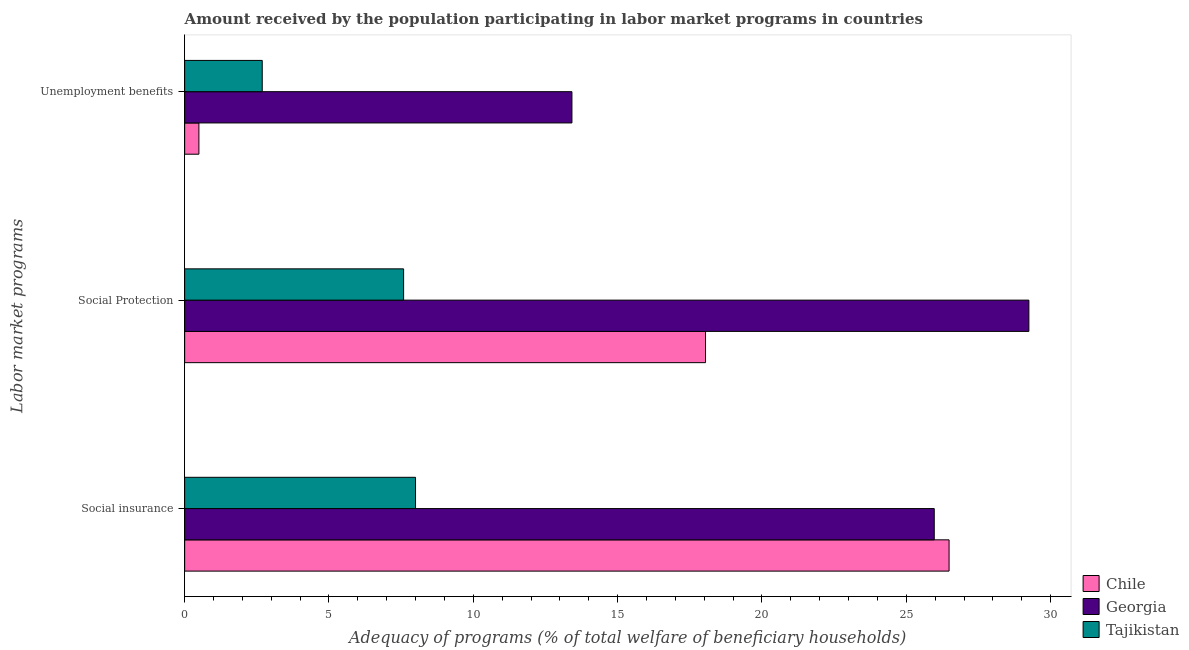How many groups of bars are there?
Offer a very short reply. 3. Are the number of bars per tick equal to the number of legend labels?
Give a very brief answer. Yes. How many bars are there on the 1st tick from the top?
Your answer should be compact. 3. How many bars are there on the 1st tick from the bottom?
Provide a succinct answer. 3. What is the label of the 1st group of bars from the top?
Give a very brief answer. Unemployment benefits. What is the amount received by the population participating in social insurance programs in Georgia?
Your answer should be compact. 25.97. Across all countries, what is the maximum amount received by the population participating in social insurance programs?
Ensure brevity in your answer.  26.48. Across all countries, what is the minimum amount received by the population participating in unemployment benefits programs?
Provide a short and direct response. 0.49. In which country was the amount received by the population participating in social insurance programs maximum?
Give a very brief answer. Chile. In which country was the amount received by the population participating in social protection programs minimum?
Your response must be concise. Tajikistan. What is the total amount received by the population participating in unemployment benefits programs in the graph?
Your answer should be compact. 16.6. What is the difference between the amount received by the population participating in social insurance programs in Georgia and that in Tajikistan?
Ensure brevity in your answer.  17.97. What is the difference between the amount received by the population participating in social protection programs in Chile and the amount received by the population participating in social insurance programs in Georgia?
Keep it short and to the point. -7.92. What is the average amount received by the population participating in social protection programs per country?
Your response must be concise. 18.29. What is the difference between the amount received by the population participating in unemployment benefits programs and amount received by the population participating in social insurance programs in Chile?
Make the answer very short. -25.99. What is the ratio of the amount received by the population participating in unemployment benefits programs in Tajikistan to that in Chile?
Your response must be concise. 5.44. Is the amount received by the population participating in social insurance programs in Tajikistan less than that in Georgia?
Offer a very short reply. Yes. What is the difference between the highest and the second highest amount received by the population participating in social insurance programs?
Ensure brevity in your answer.  0.51. What is the difference between the highest and the lowest amount received by the population participating in unemployment benefits programs?
Ensure brevity in your answer.  12.92. Is the sum of the amount received by the population participating in social protection programs in Chile and Tajikistan greater than the maximum amount received by the population participating in unemployment benefits programs across all countries?
Provide a succinct answer. Yes. What does the 2nd bar from the top in Social Protection represents?
Your answer should be compact. Georgia. What does the 3rd bar from the bottom in Social Protection represents?
Ensure brevity in your answer.  Tajikistan. Are all the bars in the graph horizontal?
Ensure brevity in your answer.  Yes. How many countries are there in the graph?
Your response must be concise. 3. Are the values on the major ticks of X-axis written in scientific E-notation?
Offer a very short reply. No. Does the graph contain grids?
Provide a short and direct response. No. How many legend labels are there?
Offer a terse response. 3. What is the title of the graph?
Make the answer very short. Amount received by the population participating in labor market programs in countries. Does "Arab World" appear as one of the legend labels in the graph?
Make the answer very short. No. What is the label or title of the X-axis?
Give a very brief answer. Adequacy of programs (% of total welfare of beneficiary households). What is the label or title of the Y-axis?
Ensure brevity in your answer.  Labor market programs. What is the Adequacy of programs (% of total welfare of beneficiary households) of Chile in Social insurance?
Your response must be concise. 26.48. What is the Adequacy of programs (% of total welfare of beneficiary households) of Georgia in Social insurance?
Your response must be concise. 25.97. What is the Adequacy of programs (% of total welfare of beneficiary households) of Tajikistan in Social insurance?
Provide a short and direct response. 8. What is the Adequacy of programs (% of total welfare of beneficiary households) in Chile in Social Protection?
Give a very brief answer. 18.05. What is the Adequacy of programs (% of total welfare of beneficiary households) in Georgia in Social Protection?
Your answer should be compact. 29.25. What is the Adequacy of programs (% of total welfare of beneficiary households) in Tajikistan in Social Protection?
Offer a terse response. 7.59. What is the Adequacy of programs (% of total welfare of beneficiary households) of Chile in Unemployment benefits?
Provide a succinct answer. 0.49. What is the Adequacy of programs (% of total welfare of beneficiary households) in Georgia in Unemployment benefits?
Your response must be concise. 13.42. What is the Adequacy of programs (% of total welfare of beneficiary households) of Tajikistan in Unemployment benefits?
Provide a short and direct response. 2.69. Across all Labor market programs, what is the maximum Adequacy of programs (% of total welfare of beneficiary households) of Chile?
Keep it short and to the point. 26.48. Across all Labor market programs, what is the maximum Adequacy of programs (% of total welfare of beneficiary households) in Georgia?
Your answer should be compact. 29.25. Across all Labor market programs, what is the maximum Adequacy of programs (% of total welfare of beneficiary households) of Tajikistan?
Offer a very short reply. 8. Across all Labor market programs, what is the minimum Adequacy of programs (% of total welfare of beneficiary households) in Chile?
Provide a short and direct response. 0.49. Across all Labor market programs, what is the minimum Adequacy of programs (% of total welfare of beneficiary households) of Georgia?
Your answer should be compact. 13.42. Across all Labor market programs, what is the minimum Adequacy of programs (% of total welfare of beneficiary households) in Tajikistan?
Your answer should be compact. 2.69. What is the total Adequacy of programs (% of total welfare of beneficiary households) in Chile in the graph?
Give a very brief answer. 45.02. What is the total Adequacy of programs (% of total welfare of beneficiary households) of Georgia in the graph?
Give a very brief answer. 68.63. What is the total Adequacy of programs (% of total welfare of beneficiary households) in Tajikistan in the graph?
Your answer should be very brief. 18.27. What is the difference between the Adequacy of programs (% of total welfare of beneficiary households) of Chile in Social insurance and that in Social Protection?
Provide a succinct answer. 8.44. What is the difference between the Adequacy of programs (% of total welfare of beneficiary households) of Georgia in Social insurance and that in Social Protection?
Offer a terse response. -3.28. What is the difference between the Adequacy of programs (% of total welfare of beneficiary households) of Tajikistan in Social insurance and that in Social Protection?
Provide a short and direct response. 0.41. What is the difference between the Adequacy of programs (% of total welfare of beneficiary households) of Chile in Social insurance and that in Unemployment benefits?
Your answer should be very brief. 25.99. What is the difference between the Adequacy of programs (% of total welfare of beneficiary households) in Georgia in Social insurance and that in Unemployment benefits?
Your answer should be compact. 12.55. What is the difference between the Adequacy of programs (% of total welfare of beneficiary households) of Tajikistan in Social insurance and that in Unemployment benefits?
Offer a terse response. 5.31. What is the difference between the Adequacy of programs (% of total welfare of beneficiary households) of Chile in Social Protection and that in Unemployment benefits?
Your answer should be compact. 17.55. What is the difference between the Adequacy of programs (% of total welfare of beneficiary households) of Georgia in Social Protection and that in Unemployment benefits?
Ensure brevity in your answer.  15.83. What is the difference between the Adequacy of programs (% of total welfare of beneficiary households) of Tajikistan in Social Protection and that in Unemployment benefits?
Provide a short and direct response. 4.9. What is the difference between the Adequacy of programs (% of total welfare of beneficiary households) of Chile in Social insurance and the Adequacy of programs (% of total welfare of beneficiary households) of Georgia in Social Protection?
Provide a succinct answer. -2.76. What is the difference between the Adequacy of programs (% of total welfare of beneficiary households) of Chile in Social insurance and the Adequacy of programs (% of total welfare of beneficiary households) of Tajikistan in Social Protection?
Your answer should be very brief. 18.9. What is the difference between the Adequacy of programs (% of total welfare of beneficiary households) of Georgia in Social insurance and the Adequacy of programs (% of total welfare of beneficiary households) of Tajikistan in Social Protection?
Make the answer very short. 18.38. What is the difference between the Adequacy of programs (% of total welfare of beneficiary households) of Chile in Social insurance and the Adequacy of programs (% of total welfare of beneficiary households) of Georgia in Unemployment benefits?
Keep it short and to the point. 13.07. What is the difference between the Adequacy of programs (% of total welfare of beneficiary households) in Chile in Social insurance and the Adequacy of programs (% of total welfare of beneficiary households) in Tajikistan in Unemployment benefits?
Offer a very short reply. 23.79. What is the difference between the Adequacy of programs (% of total welfare of beneficiary households) of Georgia in Social insurance and the Adequacy of programs (% of total welfare of beneficiary households) of Tajikistan in Unemployment benefits?
Your response must be concise. 23.28. What is the difference between the Adequacy of programs (% of total welfare of beneficiary households) in Chile in Social Protection and the Adequacy of programs (% of total welfare of beneficiary households) in Georgia in Unemployment benefits?
Provide a short and direct response. 4.63. What is the difference between the Adequacy of programs (% of total welfare of beneficiary households) in Chile in Social Protection and the Adequacy of programs (% of total welfare of beneficiary households) in Tajikistan in Unemployment benefits?
Offer a very short reply. 15.36. What is the difference between the Adequacy of programs (% of total welfare of beneficiary households) of Georgia in Social Protection and the Adequacy of programs (% of total welfare of beneficiary households) of Tajikistan in Unemployment benefits?
Your response must be concise. 26.56. What is the average Adequacy of programs (% of total welfare of beneficiary households) of Chile per Labor market programs?
Make the answer very short. 15.01. What is the average Adequacy of programs (% of total welfare of beneficiary households) of Georgia per Labor market programs?
Offer a very short reply. 22.88. What is the average Adequacy of programs (% of total welfare of beneficiary households) of Tajikistan per Labor market programs?
Provide a short and direct response. 6.09. What is the difference between the Adequacy of programs (% of total welfare of beneficiary households) in Chile and Adequacy of programs (% of total welfare of beneficiary households) in Georgia in Social insurance?
Offer a very short reply. 0.51. What is the difference between the Adequacy of programs (% of total welfare of beneficiary households) of Chile and Adequacy of programs (% of total welfare of beneficiary households) of Tajikistan in Social insurance?
Make the answer very short. 18.48. What is the difference between the Adequacy of programs (% of total welfare of beneficiary households) of Georgia and Adequacy of programs (% of total welfare of beneficiary households) of Tajikistan in Social insurance?
Your answer should be compact. 17.97. What is the difference between the Adequacy of programs (% of total welfare of beneficiary households) of Chile and Adequacy of programs (% of total welfare of beneficiary households) of Georgia in Social Protection?
Provide a succinct answer. -11.2. What is the difference between the Adequacy of programs (% of total welfare of beneficiary households) in Chile and Adequacy of programs (% of total welfare of beneficiary households) in Tajikistan in Social Protection?
Your response must be concise. 10.46. What is the difference between the Adequacy of programs (% of total welfare of beneficiary households) of Georgia and Adequacy of programs (% of total welfare of beneficiary households) of Tajikistan in Social Protection?
Offer a very short reply. 21.66. What is the difference between the Adequacy of programs (% of total welfare of beneficiary households) in Chile and Adequacy of programs (% of total welfare of beneficiary households) in Georgia in Unemployment benefits?
Provide a short and direct response. -12.92. What is the difference between the Adequacy of programs (% of total welfare of beneficiary households) of Chile and Adequacy of programs (% of total welfare of beneficiary households) of Tajikistan in Unemployment benefits?
Offer a terse response. -2.19. What is the difference between the Adequacy of programs (% of total welfare of beneficiary households) of Georgia and Adequacy of programs (% of total welfare of beneficiary households) of Tajikistan in Unemployment benefits?
Your answer should be compact. 10.73. What is the ratio of the Adequacy of programs (% of total welfare of beneficiary households) of Chile in Social insurance to that in Social Protection?
Offer a terse response. 1.47. What is the ratio of the Adequacy of programs (% of total welfare of beneficiary households) of Georgia in Social insurance to that in Social Protection?
Your answer should be very brief. 0.89. What is the ratio of the Adequacy of programs (% of total welfare of beneficiary households) in Tajikistan in Social insurance to that in Social Protection?
Provide a succinct answer. 1.05. What is the ratio of the Adequacy of programs (% of total welfare of beneficiary households) of Chile in Social insurance to that in Unemployment benefits?
Offer a terse response. 53.59. What is the ratio of the Adequacy of programs (% of total welfare of beneficiary households) in Georgia in Social insurance to that in Unemployment benefits?
Ensure brevity in your answer.  1.94. What is the ratio of the Adequacy of programs (% of total welfare of beneficiary households) of Tajikistan in Social insurance to that in Unemployment benefits?
Provide a succinct answer. 2.98. What is the ratio of the Adequacy of programs (% of total welfare of beneficiary households) in Chile in Social Protection to that in Unemployment benefits?
Offer a terse response. 36.52. What is the ratio of the Adequacy of programs (% of total welfare of beneficiary households) in Georgia in Social Protection to that in Unemployment benefits?
Provide a short and direct response. 2.18. What is the ratio of the Adequacy of programs (% of total welfare of beneficiary households) of Tajikistan in Social Protection to that in Unemployment benefits?
Your answer should be compact. 2.82. What is the difference between the highest and the second highest Adequacy of programs (% of total welfare of beneficiary households) of Chile?
Offer a very short reply. 8.44. What is the difference between the highest and the second highest Adequacy of programs (% of total welfare of beneficiary households) of Georgia?
Your response must be concise. 3.28. What is the difference between the highest and the second highest Adequacy of programs (% of total welfare of beneficiary households) of Tajikistan?
Your answer should be very brief. 0.41. What is the difference between the highest and the lowest Adequacy of programs (% of total welfare of beneficiary households) in Chile?
Make the answer very short. 25.99. What is the difference between the highest and the lowest Adequacy of programs (% of total welfare of beneficiary households) in Georgia?
Keep it short and to the point. 15.83. What is the difference between the highest and the lowest Adequacy of programs (% of total welfare of beneficiary households) in Tajikistan?
Make the answer very short. 5.31. 